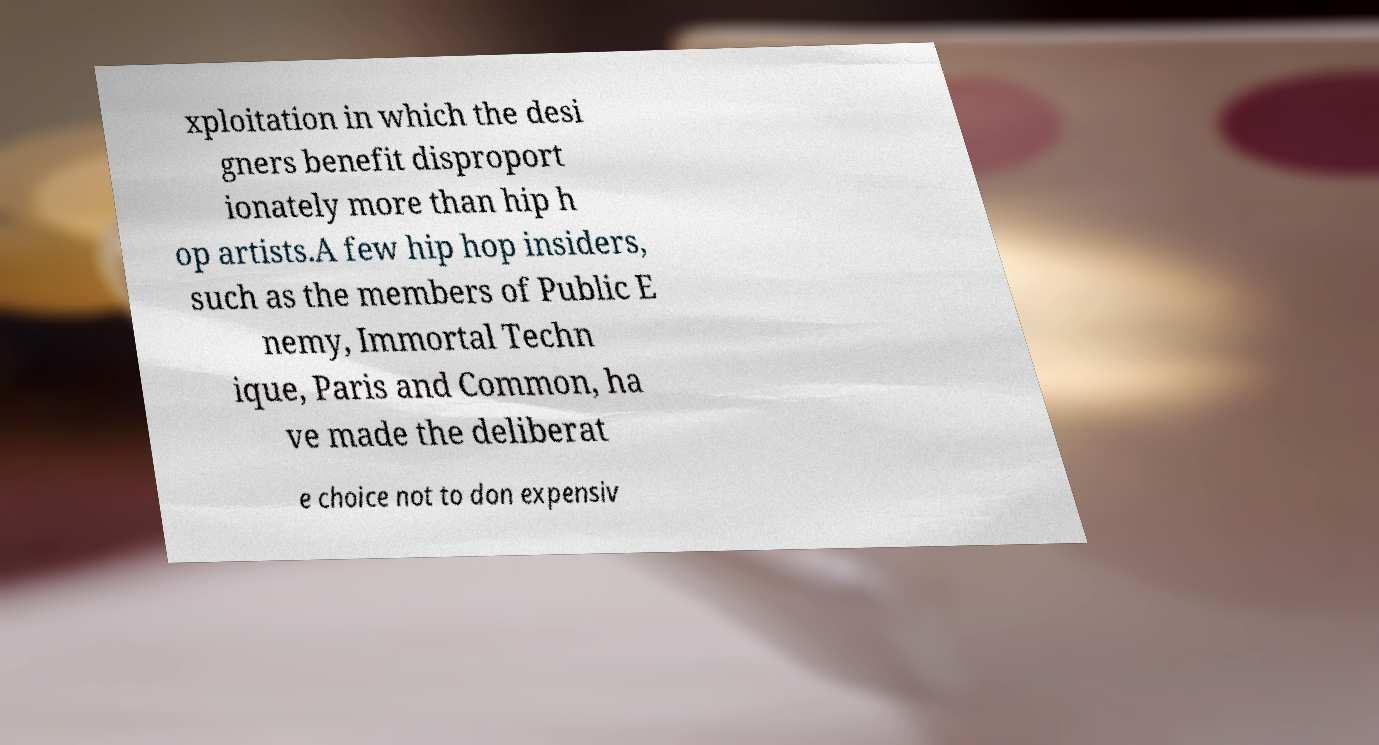I need the written content from this picture converted into text. Can you do that? xploitation in which the desi gners benefit disproport ionately more than hip h op artists.A few hip hop insiders, such as the members of Public E nemy, Immortal Techn ique, Paris and Common, ha ve made the deliberat e choice not to don expensiv 